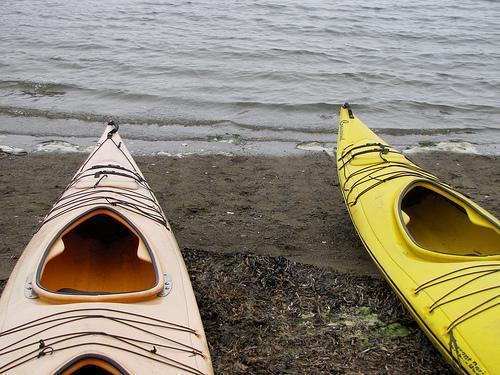How many people can sit in the all yellow kayak?
Give a very brief answer. 1. How many kayaks are there?
Give a very brief answer. 2. 